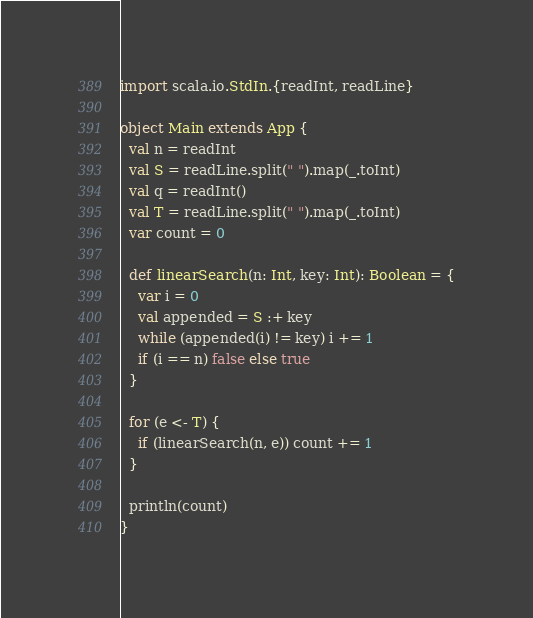Convert code to text. <code><loc_0><loc_0><loc_500><loc_500><_Scala_>import scala.io.StdIn.{readInt, readLine}

object Main extends App {
  val n = readInt
  val S = readLine.split(" ").map(_.toInt)
  val q = readInt()
  val T = readLine.split(" ").map(_.toInt)
  var count = 0

  def linearSearch(n: Int, key: Int): Boolean = {
    var i = 0
    val appended = S :+ key
    while (appended(i) != key) i += 1
    if (i == n) false else true
  }

  for (e <- T) {
    if (linearSearch(n, e)) count += 1
  }

  println(count)
}

</code> 